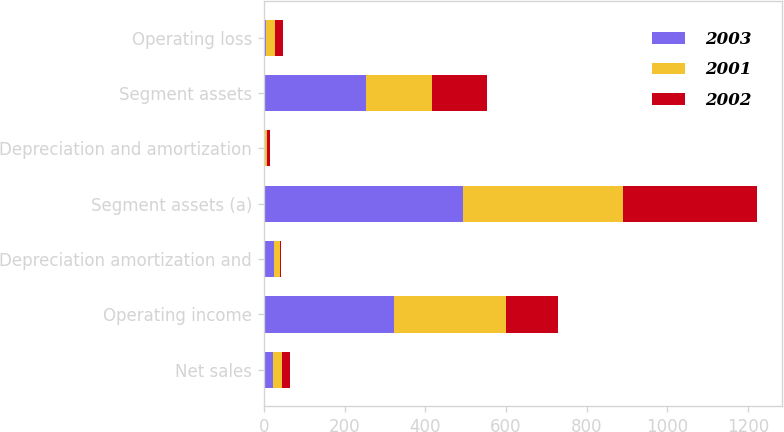Convert chart to OTSL. <chart><loc_0><loc_0><loc_500><loc_500><stacked_bar_chart><ecel><fcel>Net sales<fcel>Operating income<fcel>Depreciation amortization and<fcel>Segment assets (a)<fcel>Depreciation and amortization<fcel>Segment assets<fcel>Operating loss<nl><fcel>2003<fcel>22<fcel>323<fcel>25<fcel>494<fcel>4<fcel>252<fcel>5<nl><fcel>2001<fcel>22<fcel>278<fcel>16<fcel>395<fcel>4<fcel>165<fcel>22<nl><fcel>2002<fcel>22<fcel>128<fcel>2<fcel>334<fcel>6<fcel>137<fcel>21<nl></chart> 